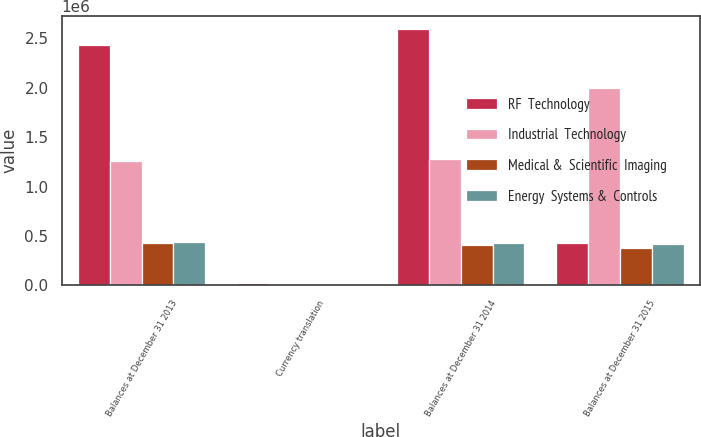Convert chart to OTSL. <chart><loc_0><loc_0><loc_500><loc_500><stacked_bar_chart><ecel><fcel>Balances at December 31 2013<fcel>Currency translation<fcel>Balances at December 31 2014<fcel>Balances at December 31 2015<nl><fcel>RF  Technology<fcel>2.43551e+06<fcel>18847<fcel>2.59436e+06<fcel>425501<nl><fcel>Industrial  Technology<fcel>1.25429e+06<fcel>7102<fcel>1.28079e+06<fcel>1.9933e+06<nl><fcel>Medical &  Scientific  Imaging<fcel>425501<fcel>16537<fcel>408964<fcel>374033<nl><fcel>Energy  Systems &  Controls<fcel>434697<fcel>8002<fcel>426583<fcel>418197<nl></chart> 